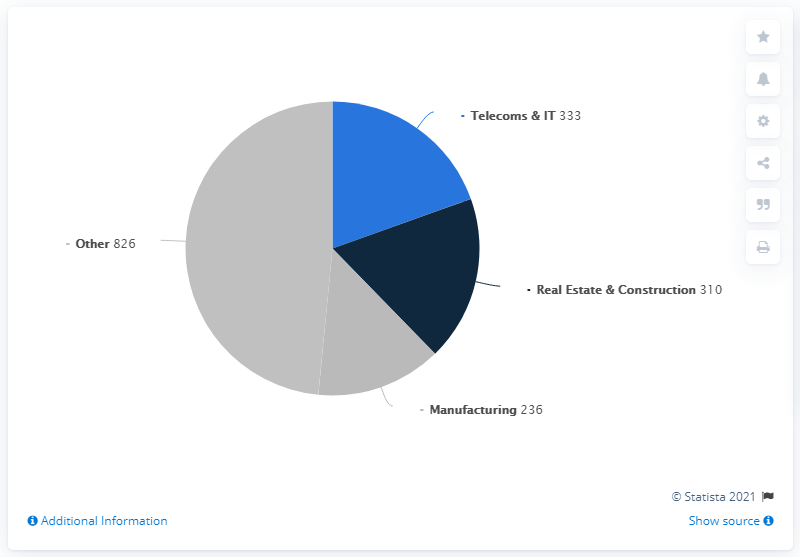List a handful of essential elements in this visual. In 2020, the telecoms and IT sector accounted for 333 mergers and acquisitions. The second most important sector is Telecoms & IT. The difference in numbers between the first and third sectors is 516. In 2020, the real estate and construction sector accounted for 310 mergers and acquisitions deals. 